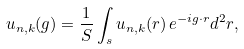<formula> <loc_0><loc_0><loc_500><loc_500>u _ { n , k } ( { g } ) = \frac { 1 } { S } \int _ { s } u _ { n , k } ( { r } ) \, e ^ { - i { g } \cdot { r } } d ^ { 2 } { r } ,</formula> 